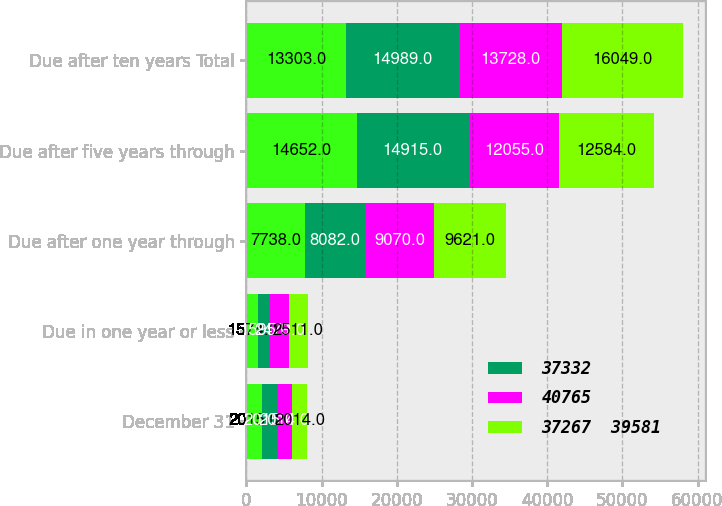Convert chart to OTSL. <chart><loc_0><loc_0><loc_500><loc_500><stacked_bar_chart><ecel><fcel>December 31<fcel>Due in one year or less<fcel>Due after one year through<fcel>Due after five years through<fcel>Due after ten years Total<nl><fcel>nan<fcel>2015<fcel>1574<fcel>7738<fcel>14652<fcel>13303<nl><fcel>37332<fcel>2015<fcel>1595<fcel>8082<fcel>14915<fcel>14989<nl><fcel>40765<fcel>2014<fcel>2479<fcel>9070<fcel>12055<fcel>13728<nl><fcel>37267  39581<fcel>2014<fcel>2511<fcel>9621<fcel>12584<fcel>16049<nl></chart> 